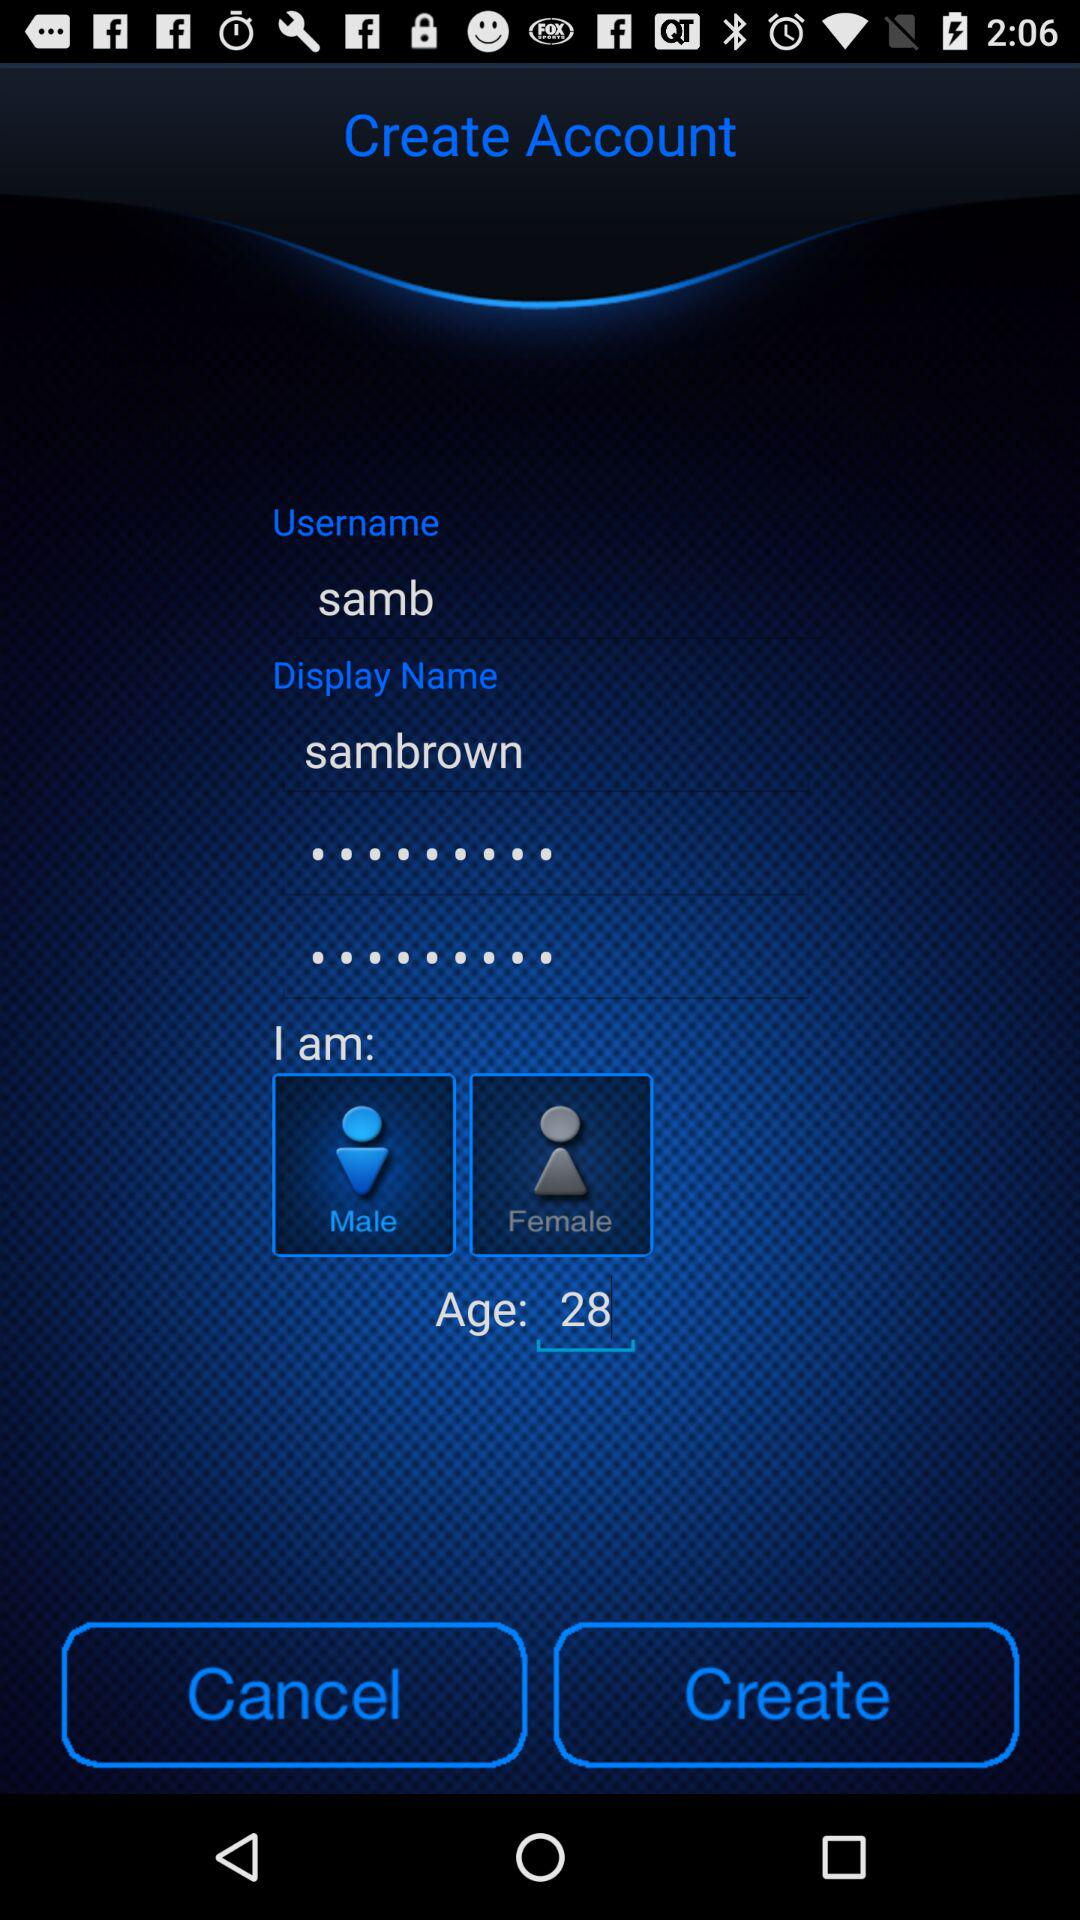What is the display name? The display name is "sambrown". 